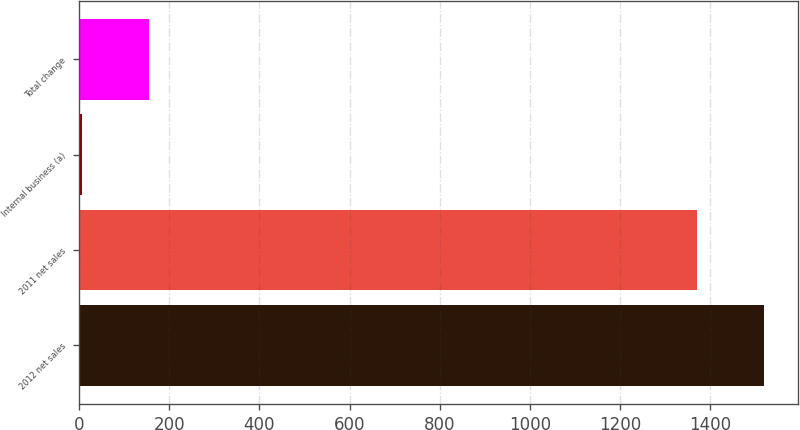<chart> <loc_0><loc_0><loc_500><loc_500><bar_chart><fcel>2012 net sales<fcel>2011 net sales<fcel>Internal business (a)<fcel>Total change<nl><fcel>1518.8<fcel>1371<fcel>7<fcel>154.8<nl></chart> 